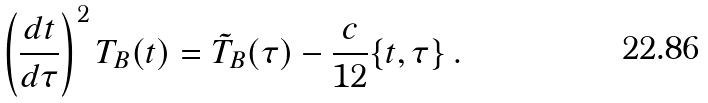<formula> <loc_0><loc_0><loc_500><loc_500>\left ( \frac { d t } { d \tau } \right ) ^ { 2 } T _ { B } ( t ) = \tilde { T } _ { B } ( \tau ) - \frac { c } { 1 2 } \{ t , \tau \} \, .</formula> 